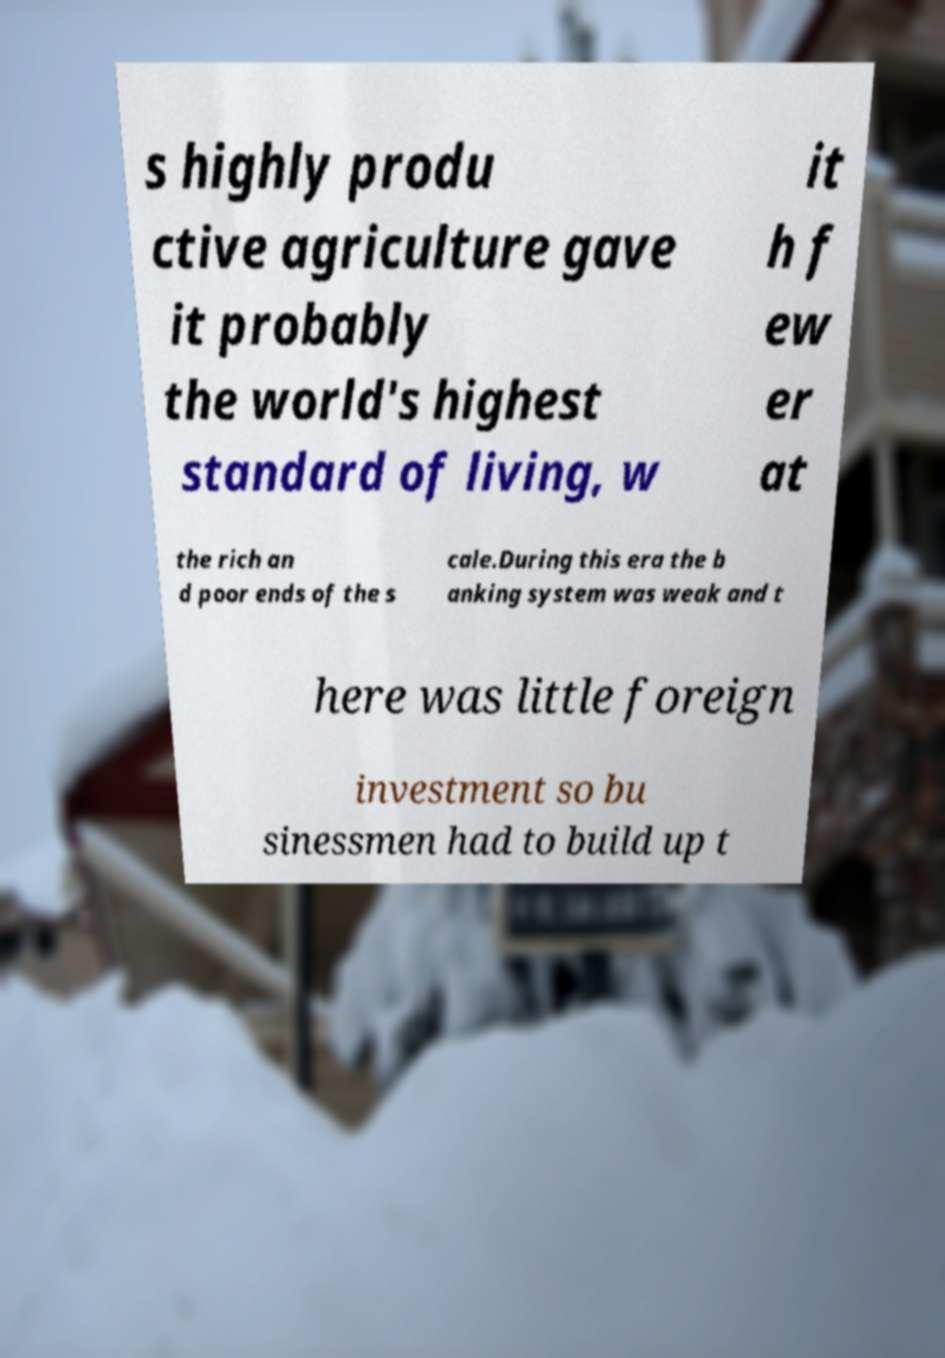Please identify and transcribe the text found in this image. s highly produ ctive agriculture gave it probably the world's highest standard of living, w it h f ew er at the rich an d poor ends of the s cale.During this era the b anking system was weak and t here was little foreign investment so bu sinessmen had to build up t 